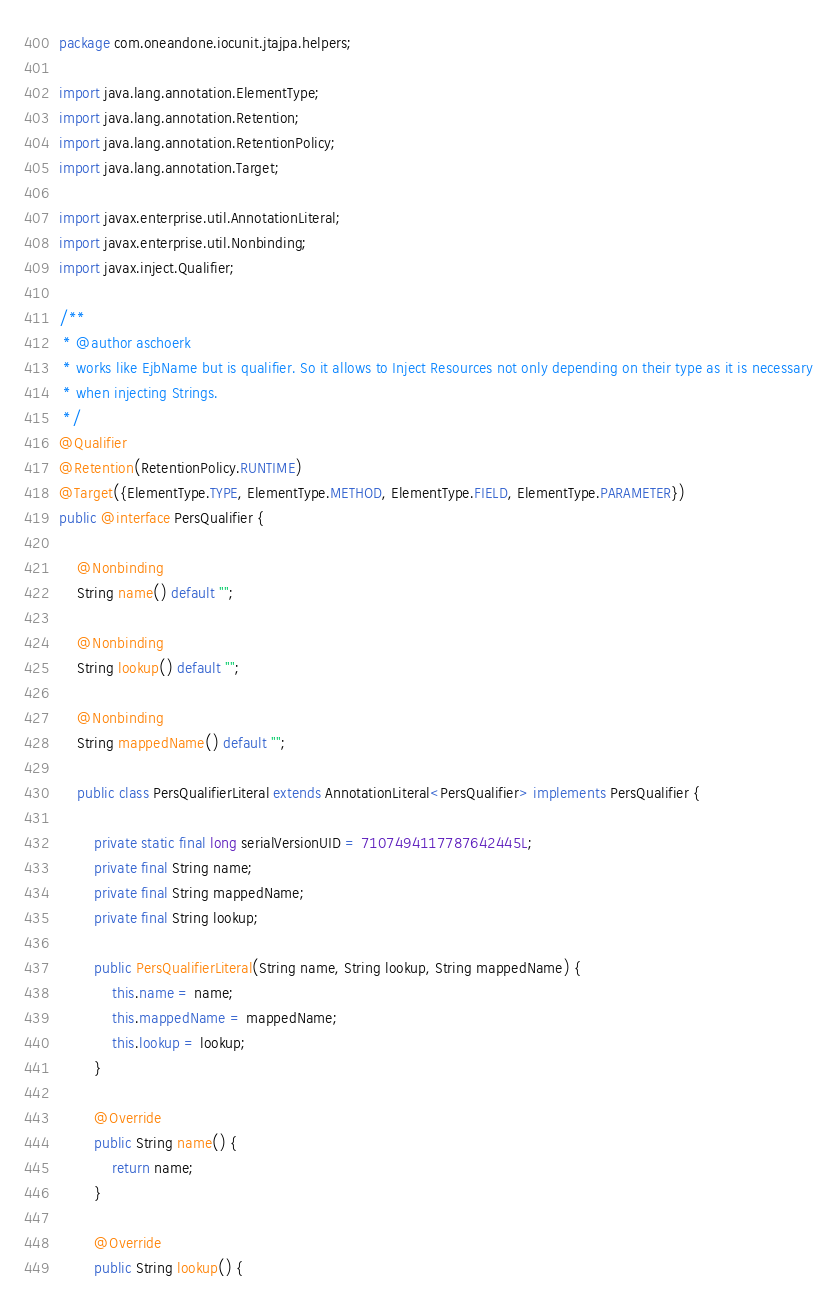Convert code to text. <code><loc_0><loc_0><loc_500><loc_500><_Java_>package com.oneandone.iocunit.jtajpa.helpers;

import java.lang.annotation.ElementType;
import java.lang.annotation.Retention;
import java.lang.annotation.RetentionPolicy;
import java.lang.annotation.Target;

import javax.enterprise.util.AnnotationLiteral;
import javax.enterprise.util.Nonbinding;
import javax.inject.Qualifier;

/**
 * @author aschoerk
 * works like EjbName but is qualifier. So it allows to Inject Resources not only depending on their type as it is necessary
 * when injecting Strings.
 */
@Qualifier
@Retention(RetentionPolicy.RUNTIME)
@Target({ElementType.TYPE, ElementType.METHOD, ElementType.FIELD, ElementType.PARAMETER})
public @interface PersQualifier {

    @Nonbinding
    String name() default "";

    @Nonbinding
    String lookup() default "";

    @Nonbinding
    String mappedName() default "";

    public class PersQualifierLiteral extends AnnotationLiteral<PersQualifier> implements PersQualifier {

        private static final long serialVersionUID = 7107494117787642445L;
        private final String name;
        private final String mappedName;
        private final String lookup;

        public PersQualifierLiteral(String name, String lookup, String mappedName) {
            this.name = name;
            this.mappedName = mappedName;
            this.lookup = lookup;
        }

        @Override
        public String name() {
            return name;
        }

        @Override
        public String lookup() {</code> 